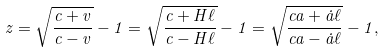<formula> <loc_0><loc_0><loc_500><loc_500>z = \sqrt { \frac { c + v } { c - v } } - 1 = \sqrt { \frac { c + H \ell } { c - H \ell } } - 1 = \sqrt { \frac { c a + \dot { a } \ell } { c a - \dot { a } \ell } } - 1 ,</formula> 